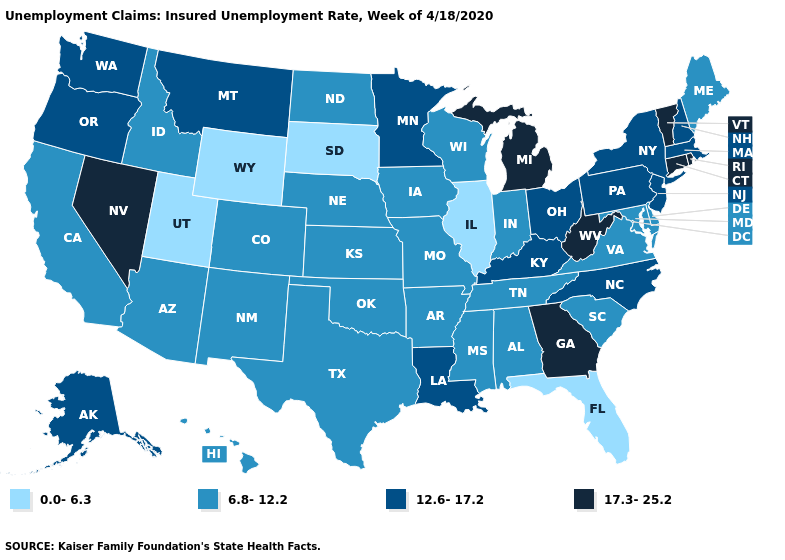Does Wyoming have the lowest value in the West?
Short answer required. Yes. Among the states that border Florida , does Georgia have the highest value?
Write a very short answer. Yes. Is the legend a continuous bar?
Short answer required. No. Name the states that have a value in the range 0.0-6.3?
Give a very brief answer. Florida, Illinois, South Dakota, Utah, Wyoming. What is the value of Massachusetts?
Answer briefly. 12.6-17.2. Does Utah have the same value as South Carolina?
Short answer required. No. Does Alabama have a higher value than Wyoming?
Give a very brief answer. Yes. Which states hav the highest value in the Northeast?
Answer briefly. Connecticut, Rhode Island, Vermont. What is the value of Washington?
Write a very short answer. 12.6-17.2. Does Tennessee have a lower value than South Dakota?
Give a very brief answer. No. Does Nevada have the same value as Alabama?
Quick response, please. No. What is the value of Delaware?
Quick response, please. 6.8-12.2. Does Montana have a higher value than New Hampshire?
Be succinct. No. What is the highest value in states that border New Mexico?
Quick response, please. 6.8-12.2. Does the first symbol in the legend represent the smallest category?
Give a very brief answer. Yes. 